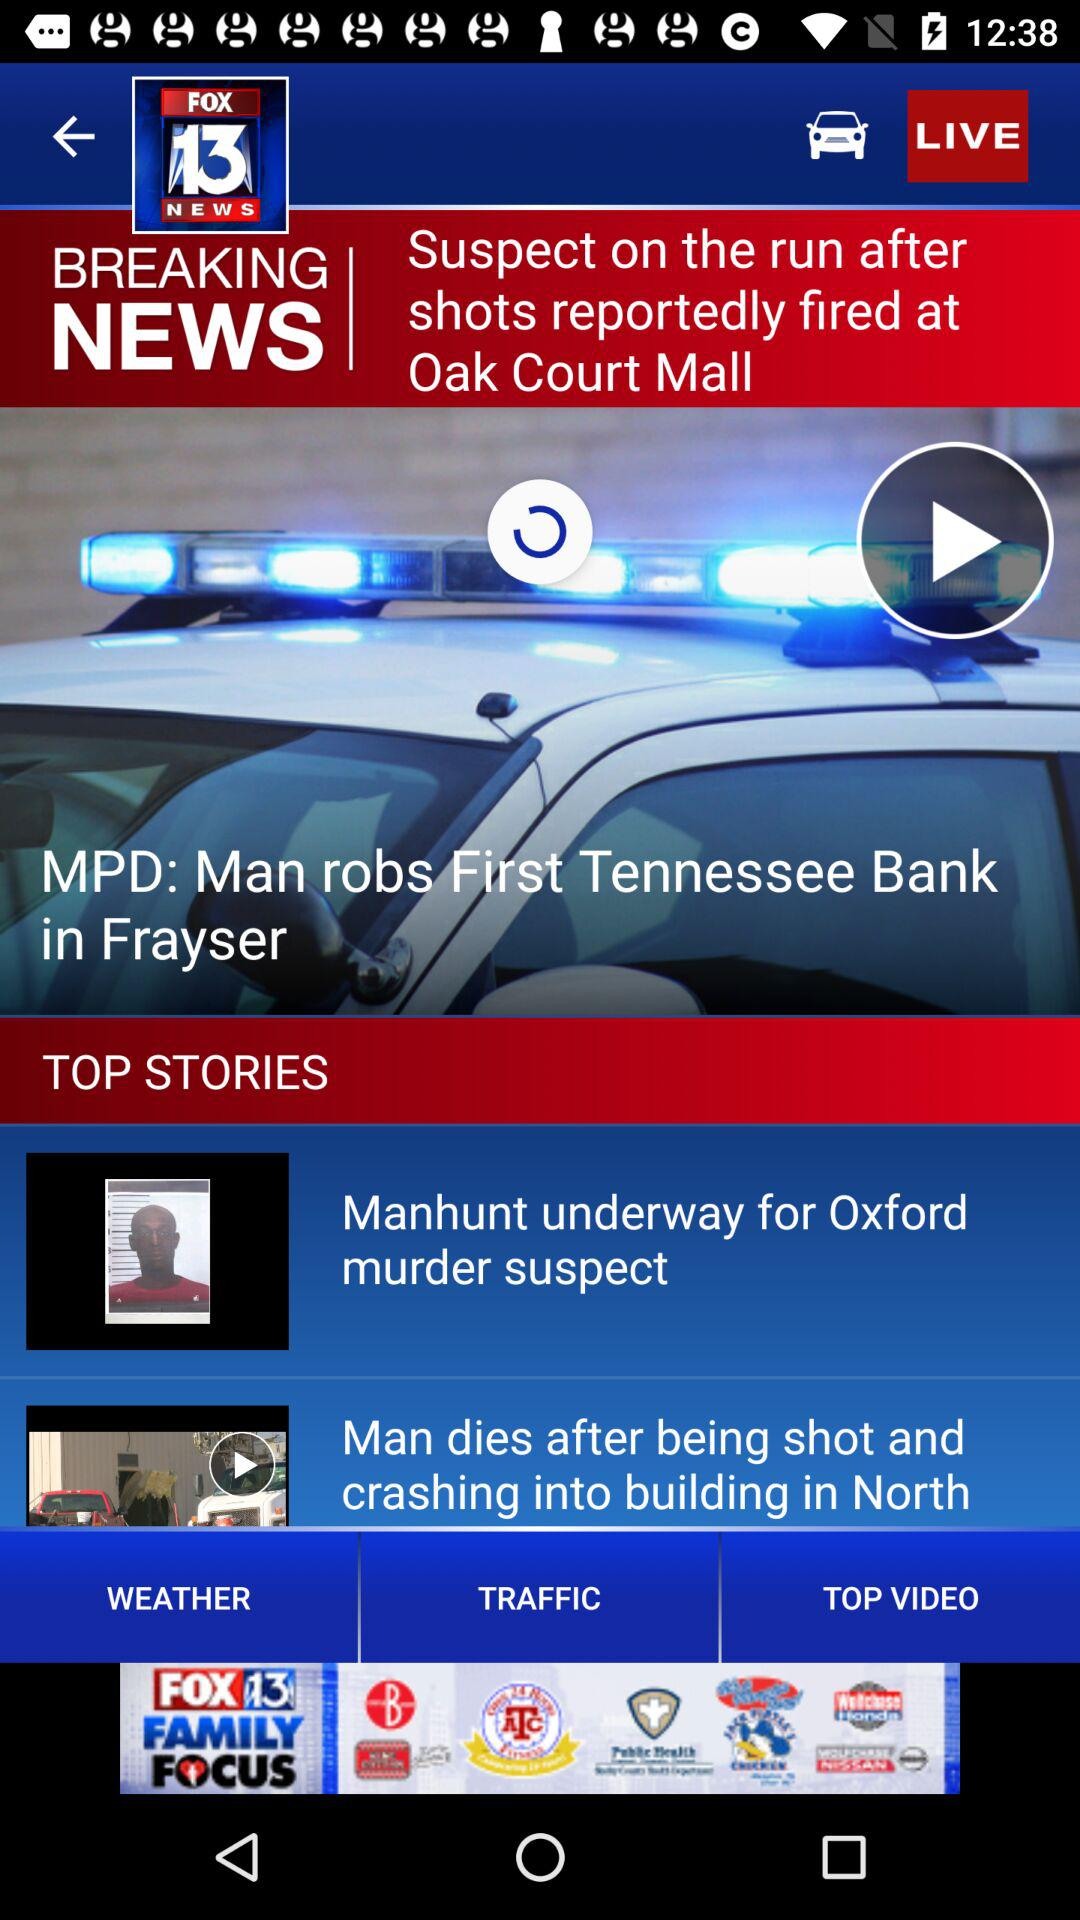What is the breaking news? The breaking news is "Suspect on the run after shots reportedly fired at Oak Court Mall". 